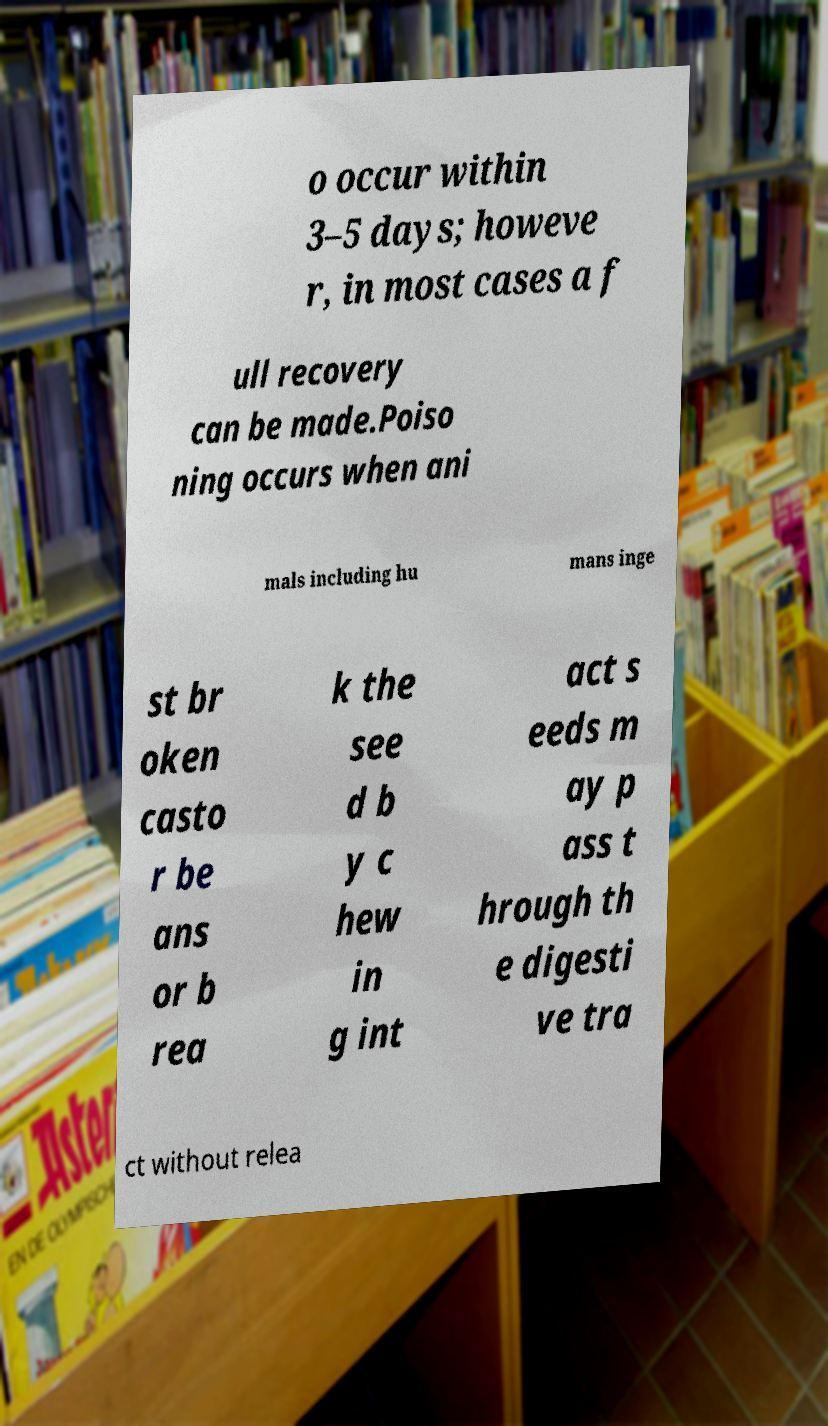Please read and relay the text visible in this image. What does it say? o occur within 3–5 days; howeve r, in most cases a f ull recovery can be made.Poiso ning occurs when ani mals including hu mans inge st br oken casto r be ans or b rea k the see d b y c hew in g int act s eeds m ay p ass t hrough th e digesti ve tra ct without relea 